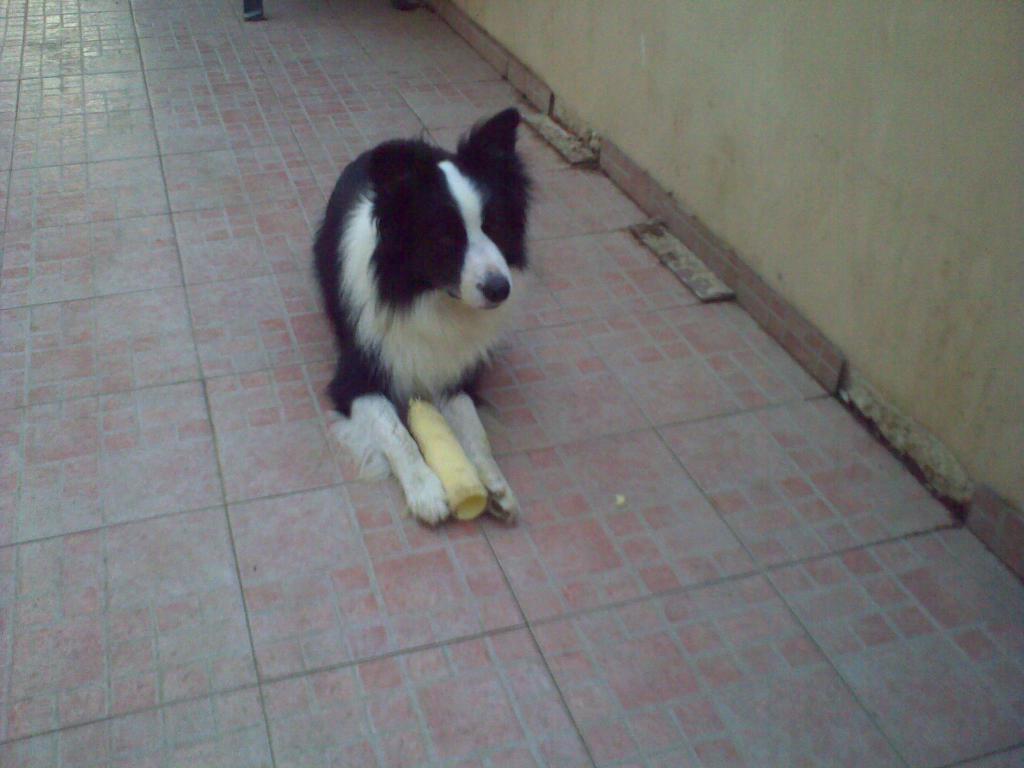How would you summarize this image in a sentence or two? In this image, we can see a dog and an object on the ground. We can see the wall. We can also see an object at the top. 